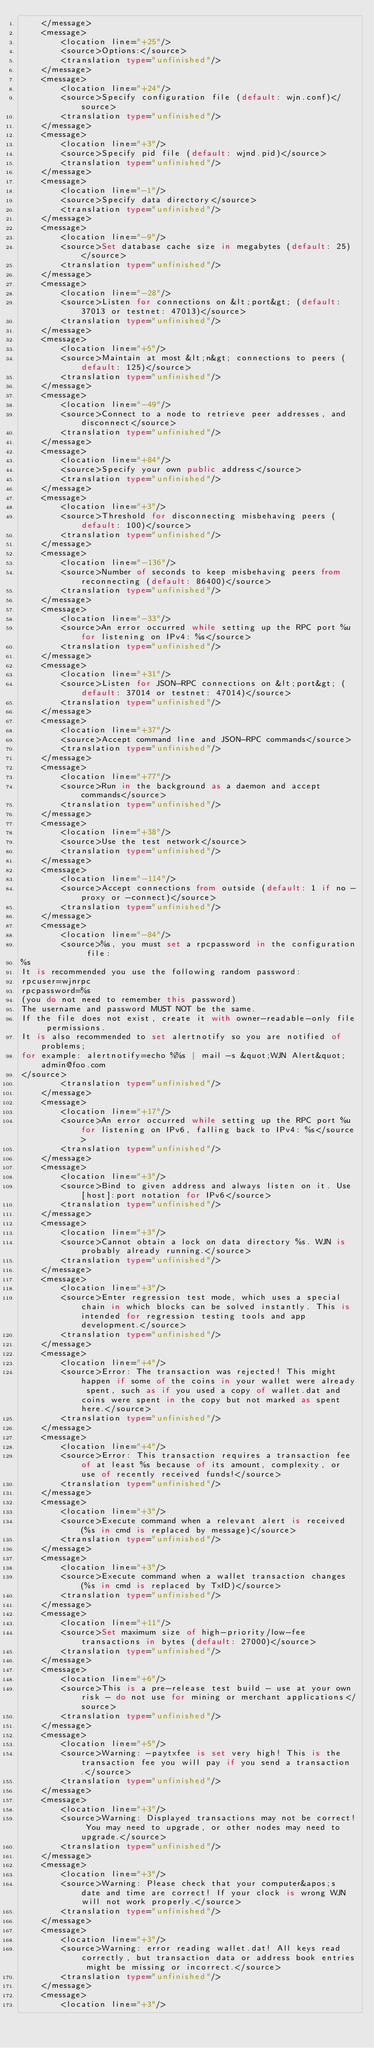<code> <loc_0><loc_0><loc_500><loc_500><_TypeScript_>    </message>
    <message>
        <location line="+25"/>
        <source>Options:</source>
        <translation type="unfinished"/>
    </message>
    <message>
        <location line="+24"/>
        <source>Specify configuration file (default: wjn.conf)</source>
        <translation type="unfinished"/>
    </message>
    <message>
        <location line="+3"/>
        <source>Specify pid file (default: wjnd.pid)</source>
        <translation type="unfinished"/>
    </message>
    <message>
        <location line="-1"/>
        <source>Specify data directory</source>
        <translation type="unfinished"/>
    </message>
    <message>
        <location line="-9"/>
        <source>Set database cache size in megabytes (default: 25)</source>
        <translation type="unfinished"/>
    </message>
    <message>
        <location line="-28"/>
        <source>Listen for connections on &lt;port&gt; (default: 37013 or testnet: 47013)</source>
        <translation type="unfinished"/>
    </message>
    <message>
        <location line="+5"/>
        <source>Maintain at most &lt;n&gt; connections to peers (default: 125)</source>
        <translation type="unfinished"/>
    </message>
    <message>
        <location line="-49"/>
        <source>Connect to a node to retrieve peer addresses, and disconnect</source>
        <translation type="unfinished"/>
    </message>
    <message>
        <location line="+84"/>
        <source>Specify your own public address</source>
        <translation type="unfinished"/>
    </message>
    <message>
        <location line="+3"/>
        <source>Threshold for disconnecting misbehaving peers (default: 100)</source>
        <translation type="unfinished"/>
    </message>
    <message>
        <location line="-136"/>
        <source>Number of seconds to keep misbehaving peers from reconnecting (default: 86400)</source>
        <translation type="unfinished"/>
    </message>
    <message>
        <location line="-33"/>
        <source>An error occurred while setting up the RPC port %u for listening on IPv4: %s</source>
        <translation type="unfinished"/>
    </message>
    <message>
        <location line="+31"/>
        <source>Listen for JSON-RPC connections on &lt;port&gt; (default: 37014 or testnet: 47014)</source>
        <translation type="unfinished"/>
    </message>
    <message>
        <location line="+37"/>
        <source>Accept command line and JSON-RPC commands</source>
        <translation type="unfinished"/>
    </message>
    <message>
        <location line="+77"/>
        <source>Run in the background as a daemon and accept commands</source>
        <translation type="unfinished"/>
    </message>
    <message>
        <location line="+38"/>
        <source>Use the test network</source>
        <translation type="unfinished"/>
    </message>
    <message>
        <location line="-114"/>
        <source>Accept connections from outside (default: 1 if no -proxy or -connect)</source>
        <translation type="unfinished"/>
    </message>
    <message>
        <location line="-84"/>
        <source>%s, you must set a rpcpassword in the configuration file:
%s
It is recommended you use the following random password:
rpcuser=wjnrpc
rpcpassword=%s
(you do not need to remember this password)
The username and password MUST NOT be the same.
If the file does not exist, create it with owner-readable-only file permissions.
It is also recommended to set alertnotify so you are notified of problems;
for example: alertnotify=echo %%s | mail -s &quot;WJN Alert&quot; admin@foo.com
</source>
        <translation type="unfinished"/>
    </message>
    <message>
        <location line="+17"/>
        <source>An error occurred while setting up the RPC port %u for listening on IPv6, falling back to IPv4: %s</source>
        <translation type="unfinished"/>
    </message>
    <message>
        <location line="+3"/>
        <source>Bind to given address and always listen on it. Use [host]:port notation for IPv6</source>
        <translation type="unfinished"/>
    </message>
    <message>
        <location line="+3"/>
        <source>Cannot obtain a lock on data directory %s. WJN is probably already running.</source>
        <translation type="unfinished"/>
    </message>
    <message>
        <location line="+3"/>
        <source>Enter regression test mode, which uses a special chain in which blocks can be solved instantly. This is intended for regression testing tools and app development.</source>
        <translation type="unfinished"/>
    </message>
    <message>
        <location line="+4"/>
        <source>Error: The transaction was rejected! This might happen if some of the coins in your wallet were already spent, such as if you used a copy of wallet.dat and coins were spent in the copy but not marked as spent here.</source>
        <translation type="unfinished"/>
    </message>
    <message>
        <location line="+4"/>
        <source>Error: This transaction requires a transaction fee of at least %s because of its amount, complexity, or use of recently received funds!</source>
        <translation type="unfinished"/>
    </message>
    <message>
        <location line="+3"/>
        <source>Execute command when a relevant alert is received (%s in cmd is replaced by message)</source>
        <translation type="unfinished"/>
    </message>
    <message>
        <location line="+3"/>
        <source>Execute command when a wallet transaction changes (%s in cmd is replaced by TxID)</source>
        <translation type="unfinished"/>
    </message>
    <message>
        <location line="+11"/>
        <source>Set maximum size of high-priority/low-fee transactions in bytes (default: 27000)</source>
        <translation type="unfinished"/>
    </message>
    <message>
        <location line="+6"/>
        <source>This is a pre-release test build - use at your own risk - do not use for mining or merchant applications</source>
        <translation type="unfinished"/>
    </message>
    <message>
        <location line="+5"/>
        <source>Warning: -paytxfee is set very high! This is the transaction fee you will pay if you send a transaction.</source>
        <translation type="unfinished"/>
    </message>
    <message>
        <location line="+3"/>
        <source>Warning: Displayed transactions may not be correct! You may need to upgrade, or other nodes may need to upgrade.</source>
        <translation type="unfinished"/>
    </message>
    <message>
        <location line="+3"/>
        <source>Warning: Please check that your computer&apos;s date and time are correct! If your clock is wrong WJN will not work properly.</source>
        <translation type="unfinished"/>
    </message>
    <message>
        <location line="+3"/>
        <source>Warning: error reading wallet.dat! All keys read correctly, but transaction data or address book entries might be missing or incorrect.</source>
        <translation type="unfinished"/>
    </message>
    <message>
        <location line="+3"/></code> 